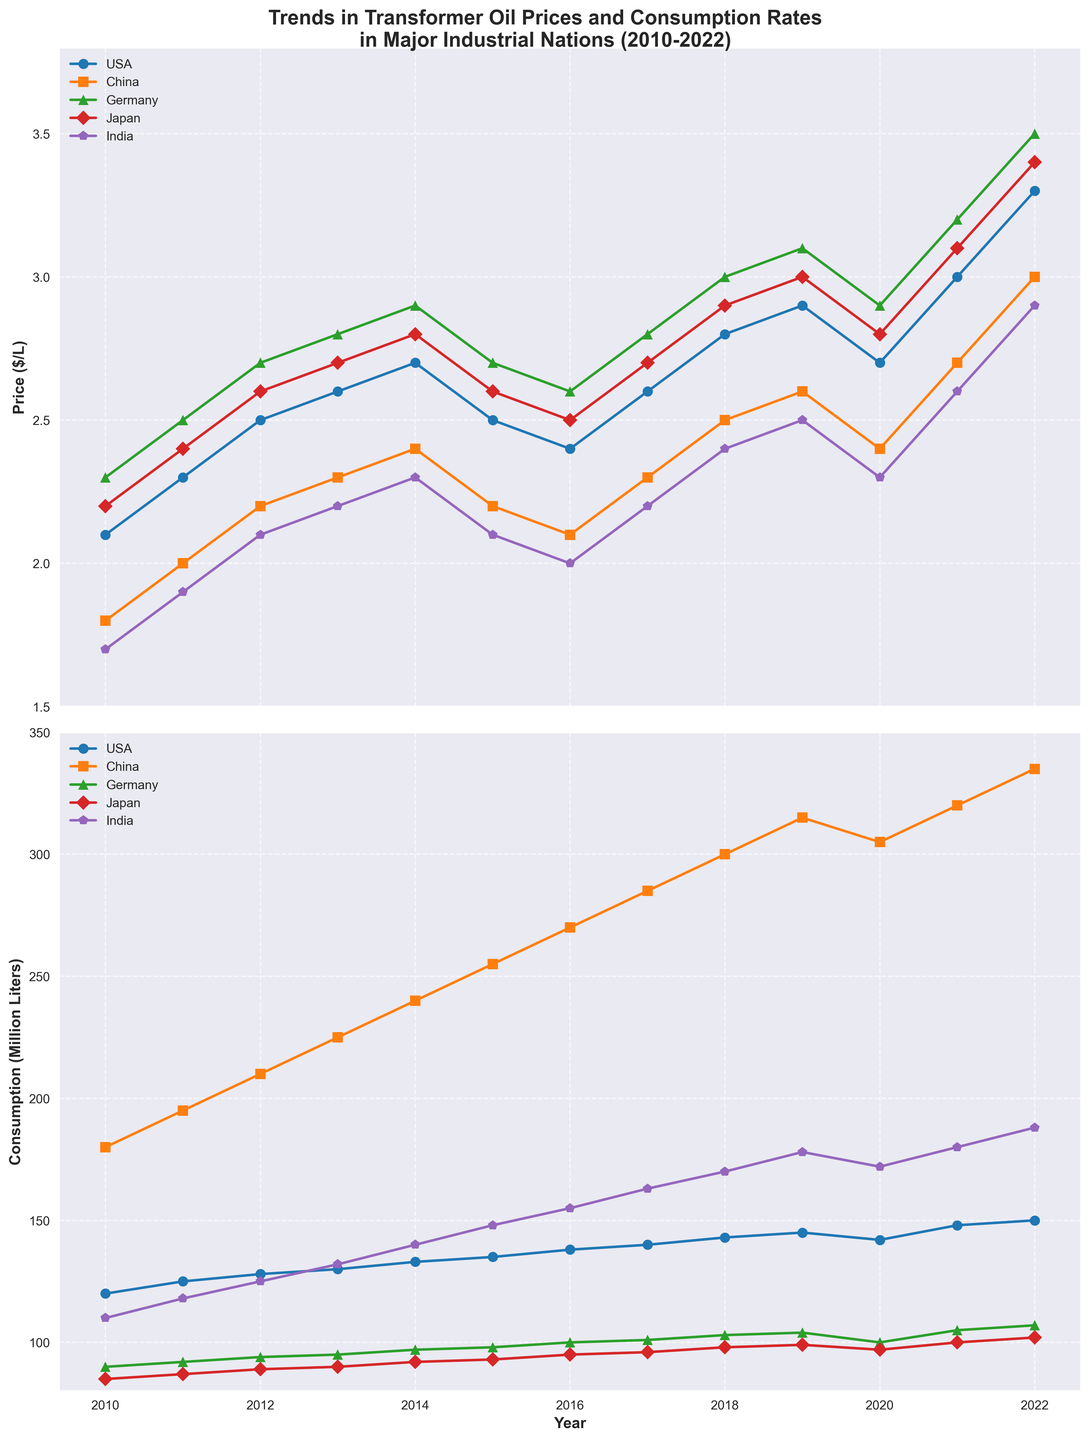What trend can be observed in transformer oil prices for the USA from 2010 to 2022? The line chart shows the trend of USA prices rising from $2.1/L in 2010 to a peak of $3.3/L in 2022, with some fluctuations such as a drop between 2014-2016 before increasing again.
Answer: Rising trend with fluctuations How does the consumption of transformer oil in China in 2018 compare to that in 2020? By examining the consumption lines, China's consumption increased from 300 million liters in 2018 to 305 million liters in 2020.
Answer: Increased by 5 million liters Which country showed the largest increase in transformer oil price from 2020 to 2022? By comparing the slopes of the price lines from 2020 to 2022, China showed the largest increase from $2.4/L to $3.0/L, which is an increase of $0.6/L.
Answer: China Between 2013 and 2016, which country had the most stable consumption of transformer oil? Germany's consumption line is the flattest between 2013 and 2016, staying around 97-100 million liters with minimal fluctuation.
Answer: Germany Calculate the average transformer oil price in India from 2010 to 2015. The average is calculated by summing the prices for each year and dividing by the number of years: (1.7+1.9+2.1+2.2+2.3+2.1) / 6 = (12.3) / 6 = 2.05.
Answer: $2.05/L Which country witnessed the highest consumption of transformer oil in 2022? The consumption line for China is the highest in 2022, reaching 335 million liters.
Answer: China Compare the trend of transformer oil prices in Germany and Japan between 2011 and 2015. Both Germany and Japan show an increasing trend from 2011 to 2014, with Germany rising from $2.5/L to $2.9/L and Japan from $2.4/L to $2.8/L. However, both countries experienced a decline in 2015, with Germany dropping to $2.7/L and Japan to $2.6/L.
Answer: Similar increasing trend with a decline in 2015 What is the sum of transformer oil consumption in the USA for the years 2019 and 2020? Summing the consumption values from the chart, 145 million liters in 2019 and 142 million liters in 2020 results in a total of 145 + 142 = 287 million liters.
Answer: 287 million liters Which country had the least fluctuation in transformer oil prices from 2010 to 2022? The price line for India shows the smoothest curve with the least variation, ranging from $1.7/L in 2010 to $2.9/L in 2022.
Answer: India 